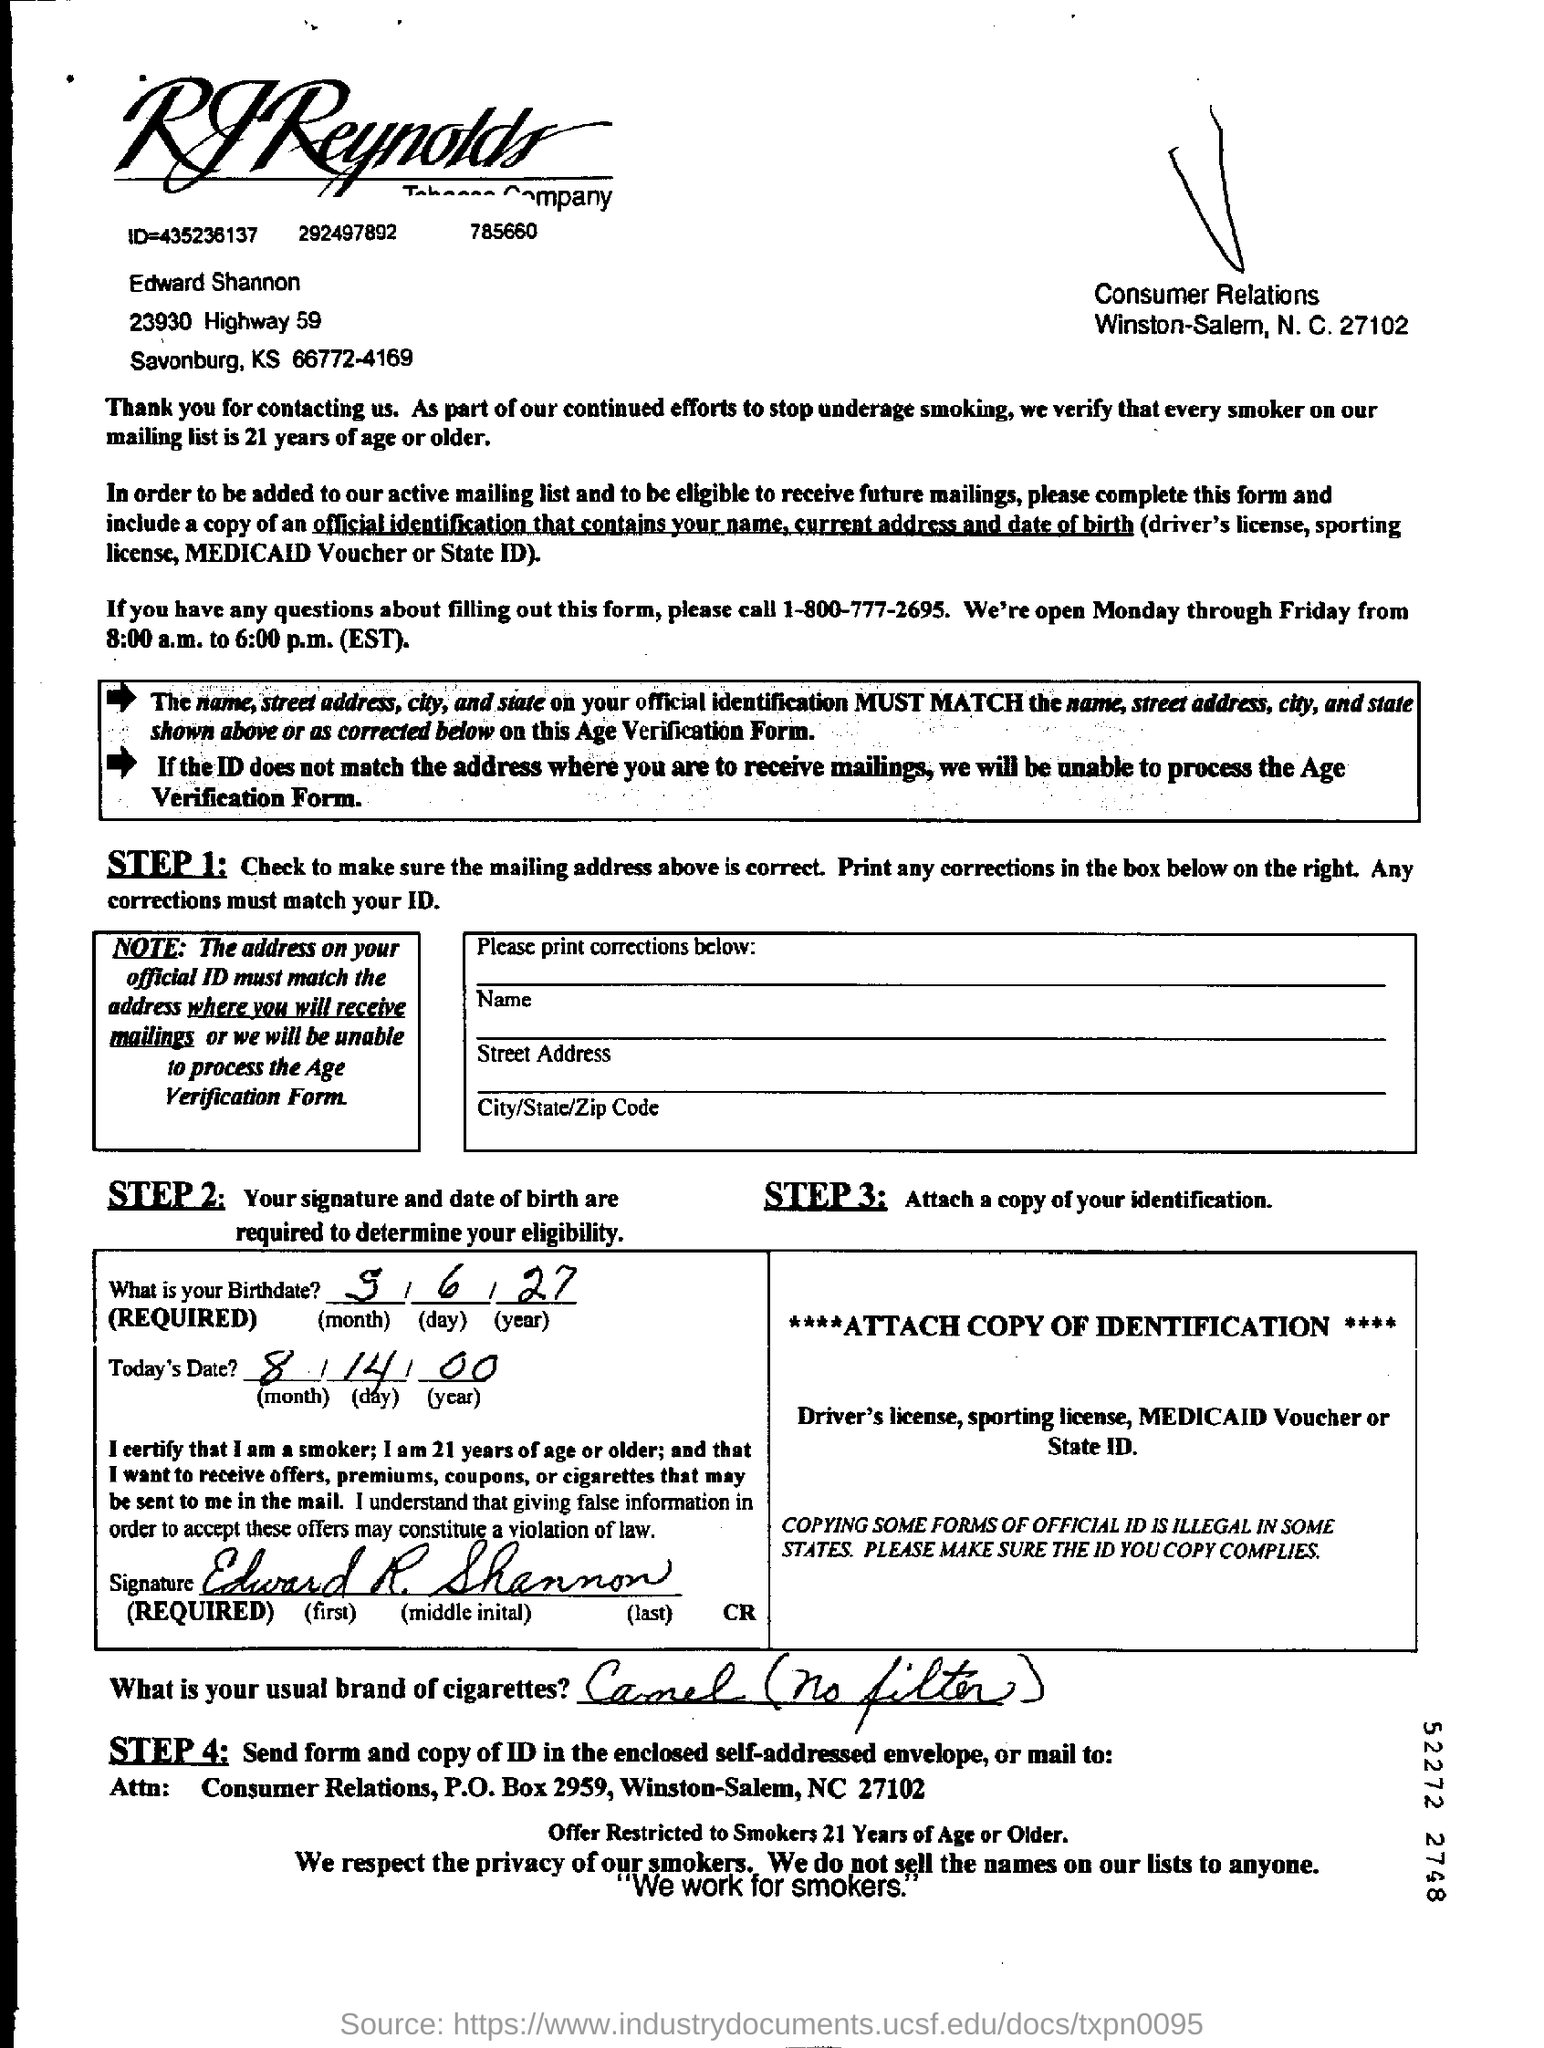Which number to call about questions on filling out this form?
Make the answer very short. 1-800-777-2695. Whose signature is given?
Make the answer very short. Edward R. Shannon. What is the date given?
Your response must be concise. 8/14/00. What is the birthdate given?
Provide a succinct answer. 5/6/27. What is Edward's usual brand of cigarettes?
Make the answer very short. Camel (no filter). 